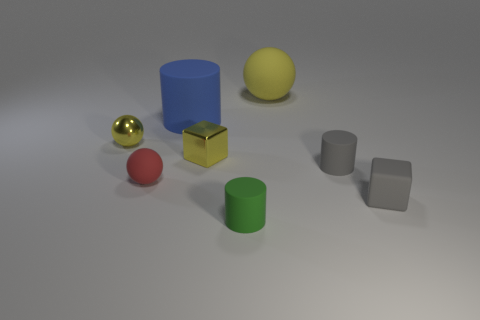Add 2 tiny yellow metal things. How many objects exist? 10 Subtract all cylinders. How many objects are left? 5 Subtract 0 cyan cylinders. How many objects are left? 8 Subtract all tiny matte cylinders. Subtract all spheres. How many objects are left? 3 Add 8 green matte cylinders. How many green matte cylinders are left? 9 Add 3 tiny rubber cylinders. How many tiny rubber cylinders exist? 5 